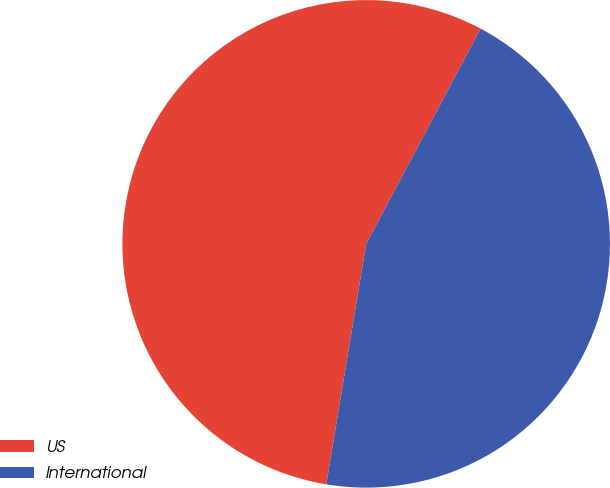<chart> <loc_0><loc_0><loc_500><loc_500><pie_chart><fcel>US<fcel>International<nl><fcel>55.16%<fcel>44.84%<nl></chart> 